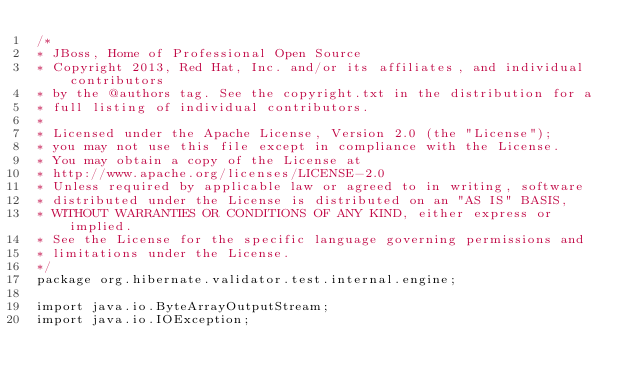<code> <loc_0><loc_0><loc_500><loc_500><_Java_>/*
* JBoss, Home of Professional Open Source
* Copyright 2013, Red Hat, Inc. and/or its affiliates, and individual contributors
* by the @authors tag. See the copyright.txt in the distribution for a
* full listing of individual contributors.
*
* Licensed under the Apache License, Version 2.0 (the "License");
* you may not use this file except in compliance with the License.
* You may obtain a copy of the License at
* http://www.apache.org/licenses/LICENSE-2.0
* Unless required by applicable law or agreed to in writing, software
* distributed under the License is distributed on an "AS IS" BASIS,
* WITHOUT WARRANTIES OR CONDITIONS OF ANY KIND, either express or implied.
* See the License for the specific language governing permissions and
* limitations under the License.
*/
package org.hibernate.validator.test.internal.engine;

import java.io.ByteArrayOutputStream;
import java.io.IOException;</code> 